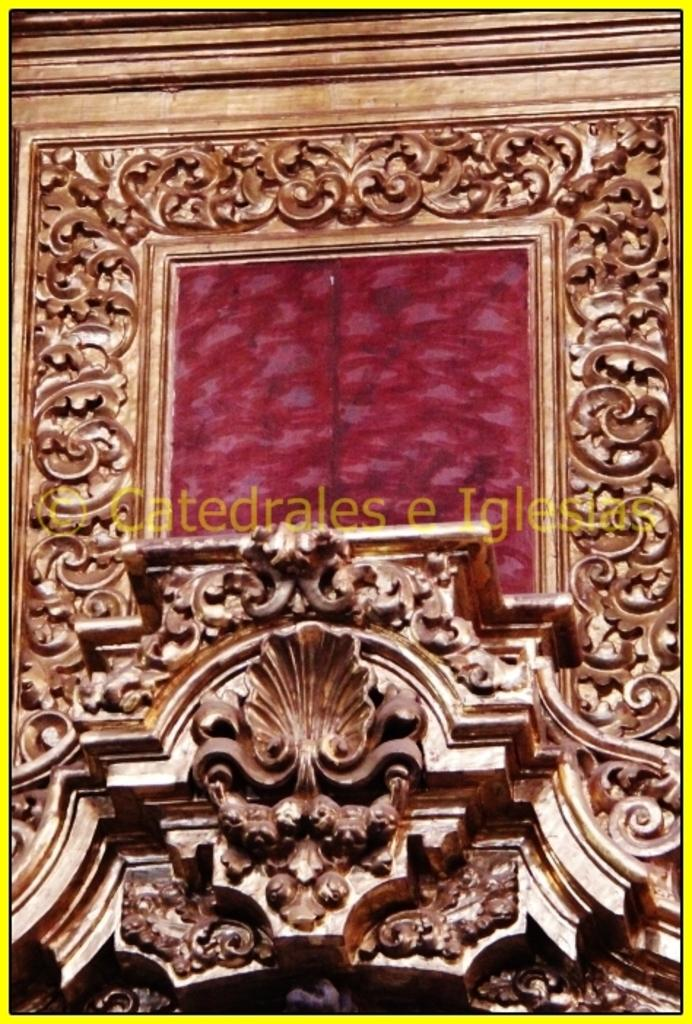<image>
Provide a brief description of the given image. A really old chapel decorative altar that looks like its made out of bronze in the middle of the image in yellow is the word church in spanish. 